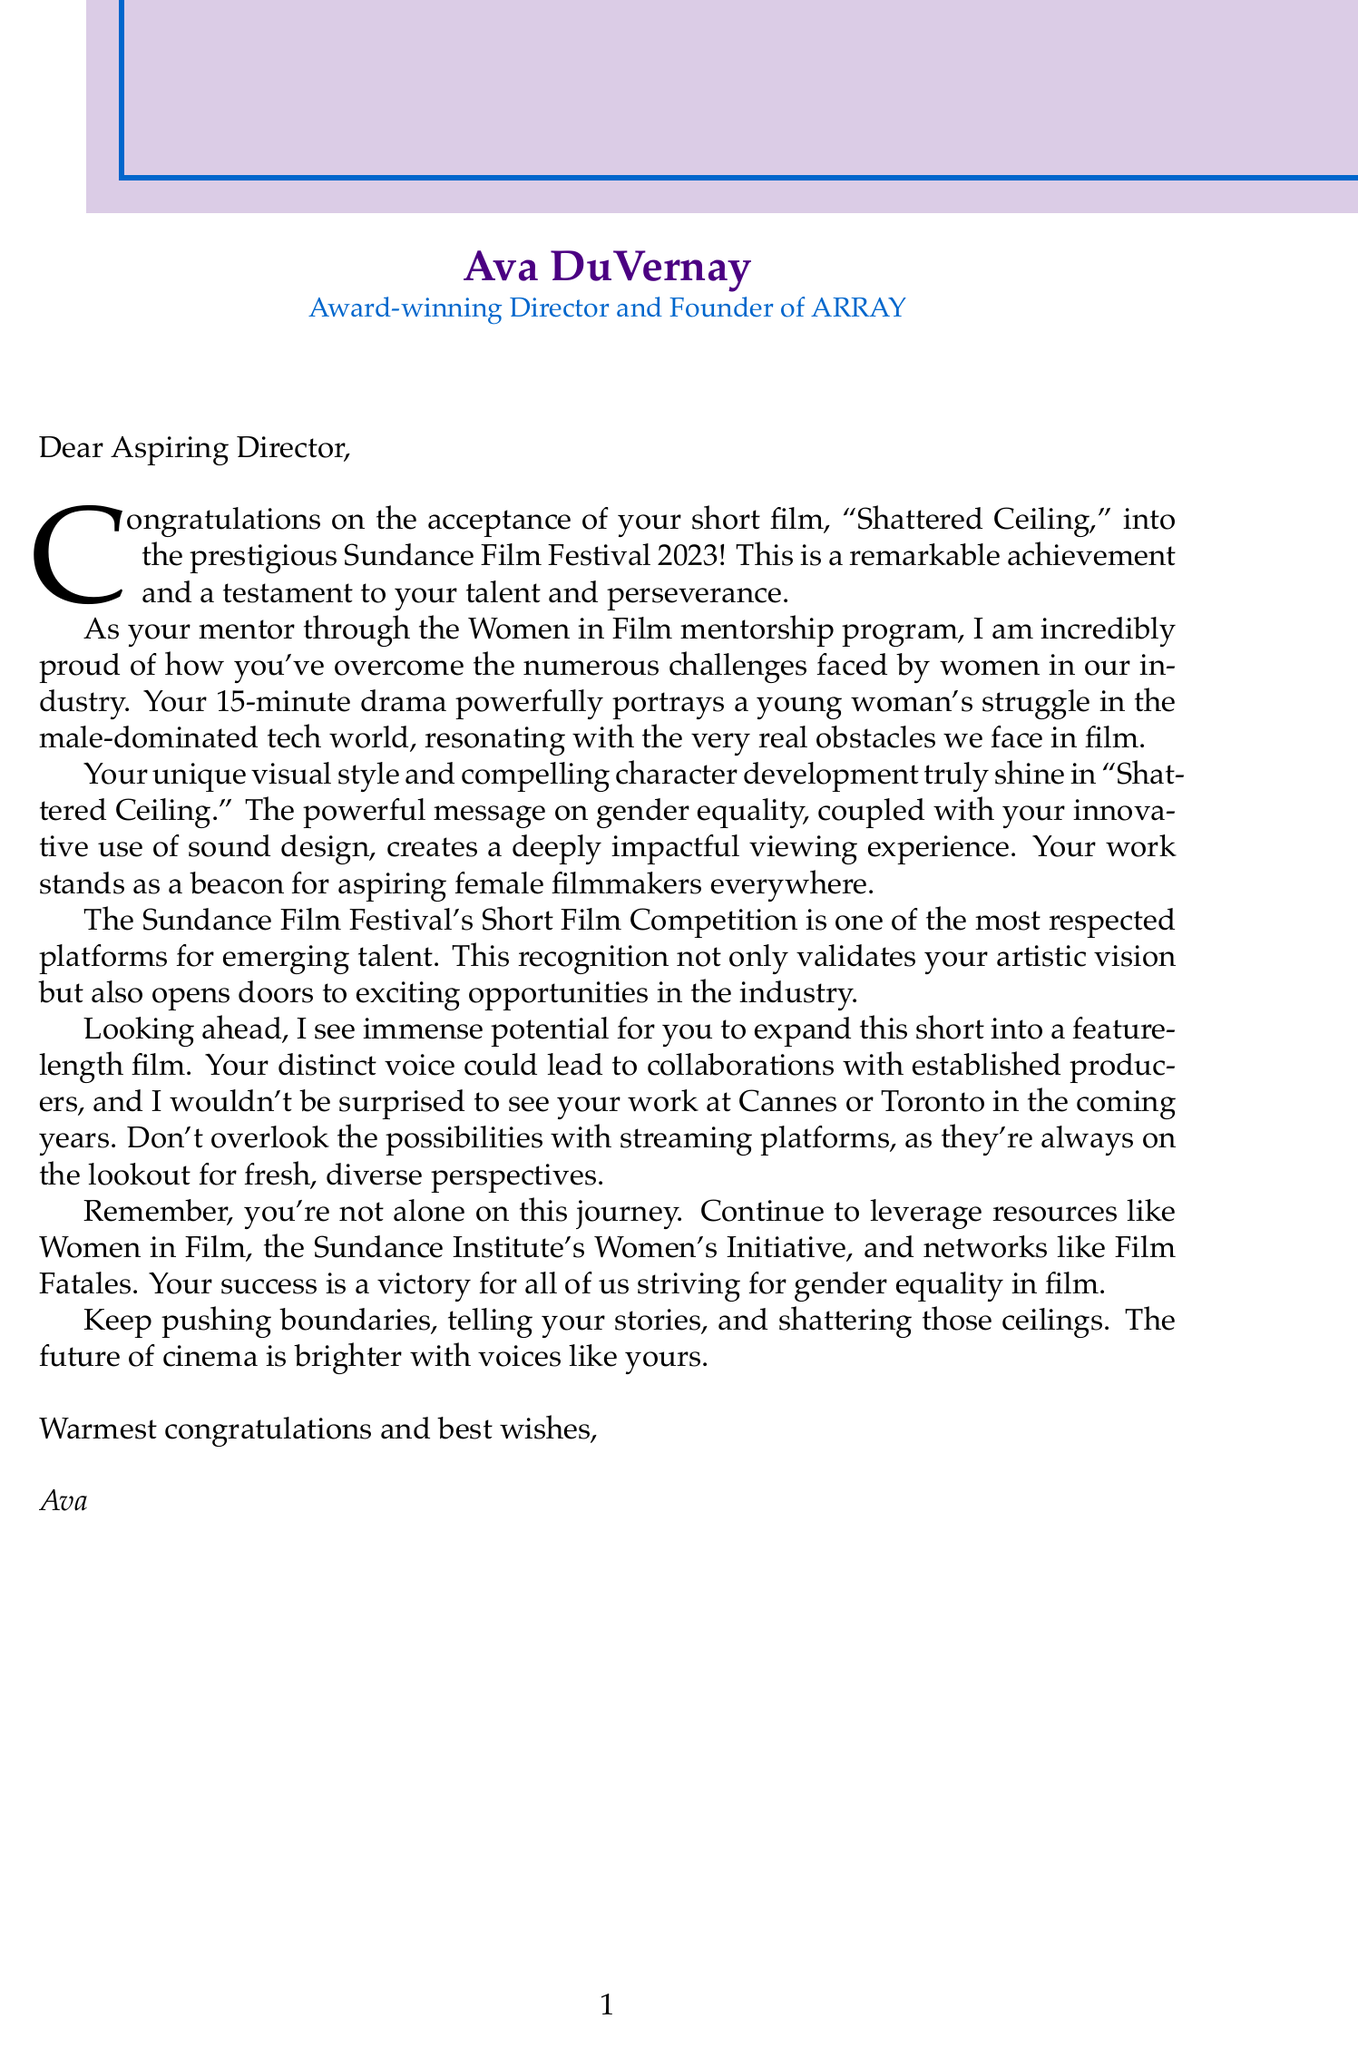What is the name of the short film? The name of the short film is mentioned in the letter and is "Shattered Ceiling."
Answer: Shattered Ceiling Who is the mentor sending the letter? The mentor's name is provided in the document, and it is Ava DuVernay.
Answer: Ava DuVernay In which festival was the short film accepted? The letter states that the short film was accepted into the Sundance Film Festival.
Answer: Sundance Film Festival What year is the festival mentioned in the letter? The letter specifies the year of the festival as 2023.
Answer: 2023 What is the genre of the short film? The genre of the short film is indicated in the letter, which is Drama.
Answer: Drama What challenges does the letter acknowledge? The letter mentions challenges women face in the industry, including gender bias in hiring and funding.
Answer: Gender bias in hiring and funding How long is the short film? The document includes the duration of the short film as 15 minutes.
Answer: 15 minutes What message does the film "Shattered Ceiling" convey? The letter highlights that the film conveys a powerful message on gender equality.
Answer: Gender equality What does the mentor encourage regarding future projects? The letter encourages the recipient to consider expanding the short into a feature-length film.
Answer: Feature-length adaptation 